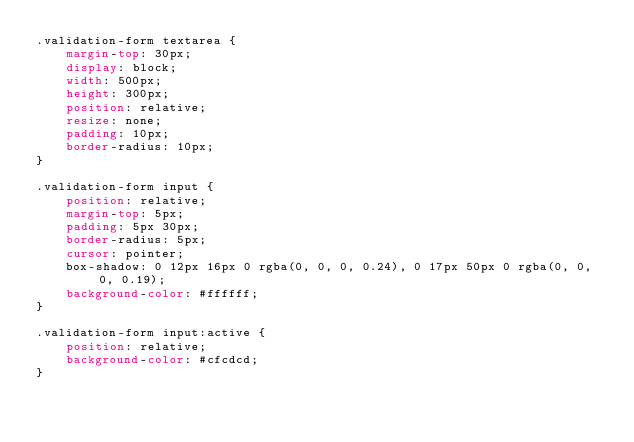Convert code to text. <code><loc_0><loc_0><loc_500><loc_500><_CSS_>.validation-form textarea {
    margin-top: 30px;
    display: block;
    width: 500px;
    height: 300px;
    position: relative;
    resize: none;
    padding: 10px;
    border-radius: 10px;
}

.validation-form input {
    position: relative;
    margin-top: 5px;
    padding: 5px 30px;
    border-radius: 5px;
    cursor: pointer;
    box-shadow: 0 12px 16px 0 rgba(0, 0, 0, 0.24), 0 17px 50px 0 rgba(0, 0, 0, 0.19);
    background-color: #ffffff;
}

.validation-form input:active {
    position: relative;
    background-color: #cfcdcd;
}
</code> 